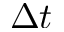Convert formula to latex. <formula><loc_0><loc_0><loc_500><loc_500>\Delta t</formula> 